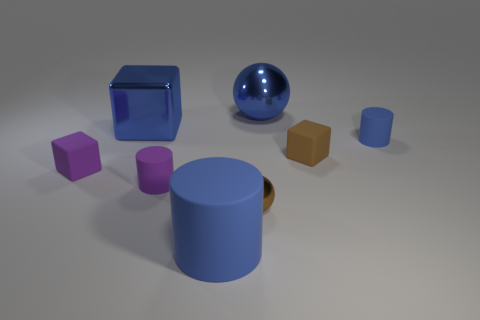Subtract 1 cylinders. How many cylinders are left? 2 Subtract all gray cubes. Subtract all blue spheres. How many cubes are left? 3 Add 1 small rubber balls. How many objects exist? 9 Subtract all balls. How many objects are left? 6 Add 8 brown things. How many brown things exist? 10 Subtract 1 brown spheres. How many objects are left? 7 Subtract all large blocks. Subtract all large blue things. How many objects are left? 4 Add 4 large blue shiny spheres. How many large blue shiny spheres are left? 5 